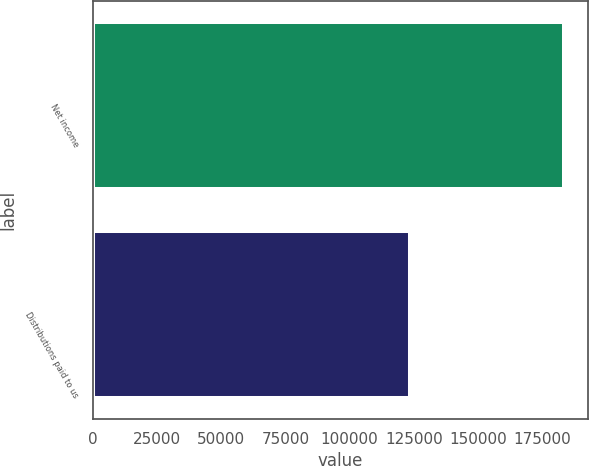Convert chart to OTSL. <chart><loc_0><loc_0><loc_500><loc_500><bar_chart><fcel>Net income<fcel>Distributions paid to us<nl><fcel>183732<fcel>123427<nl></chart> 